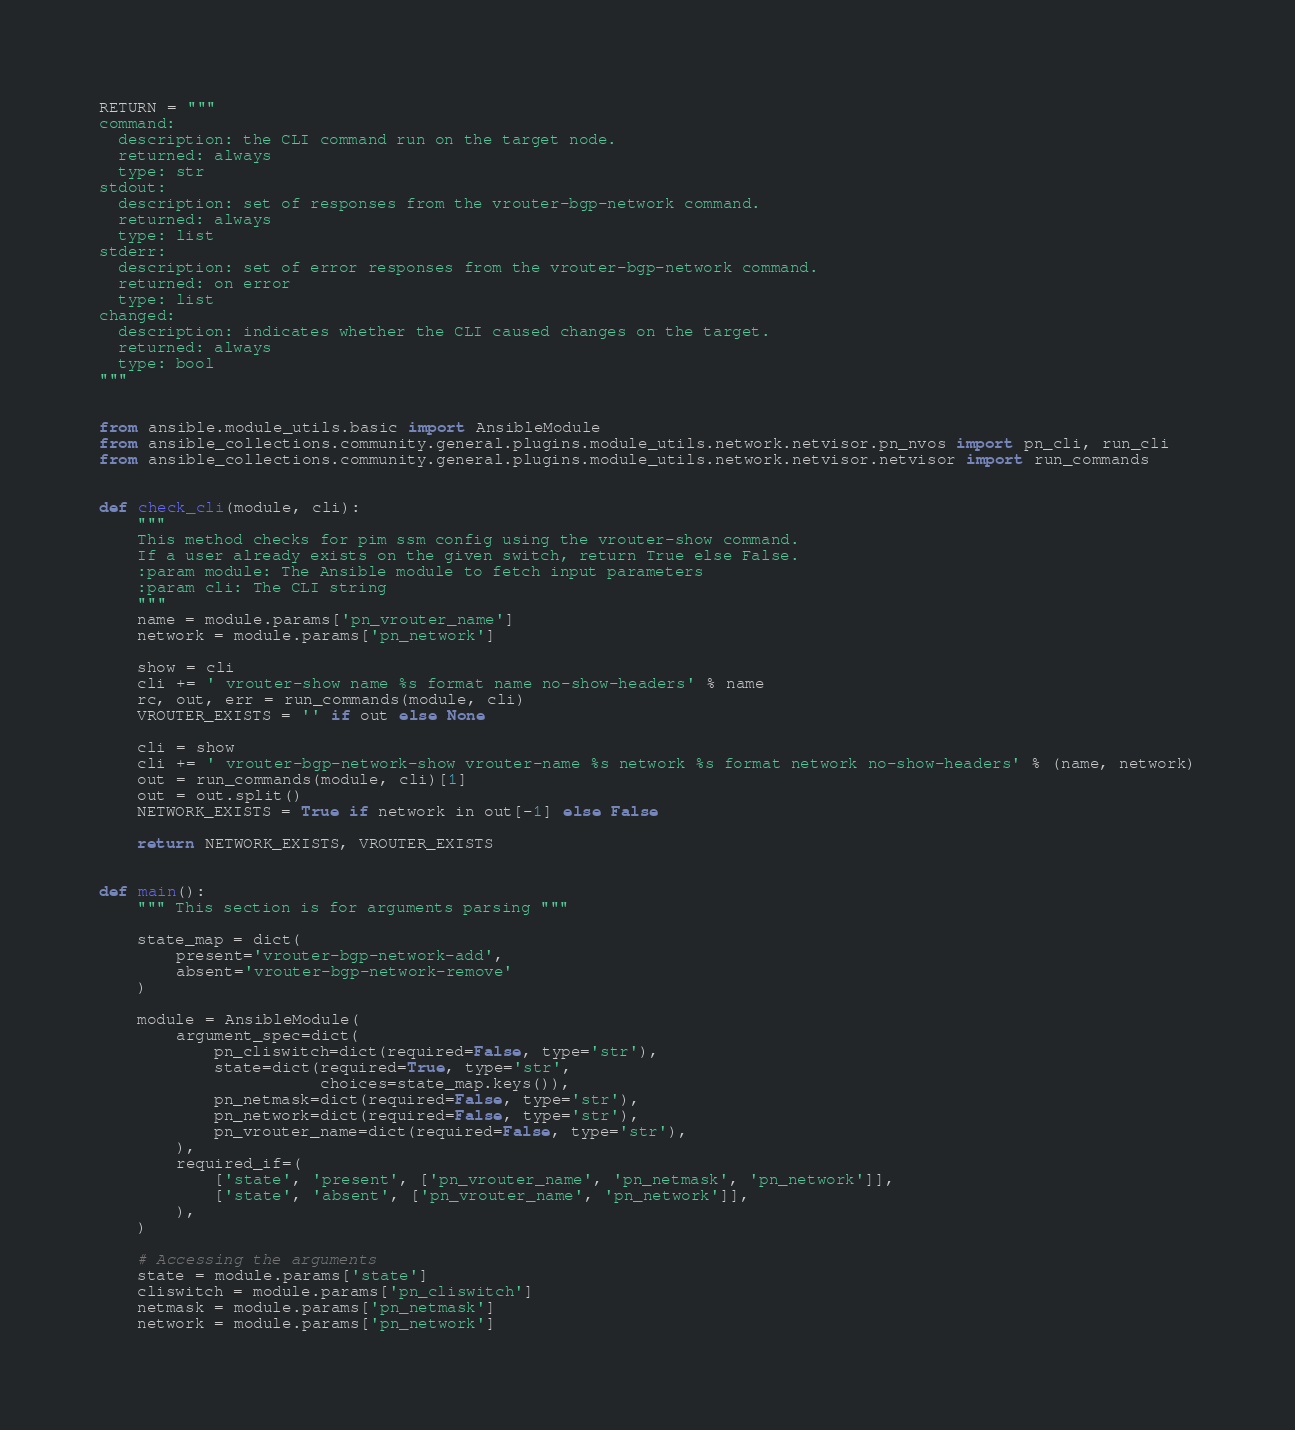<code> <loc_0><loc_0><loc_500><loc_500><_Python_>
RETURN = """
command:
  description: the CLI command run on the target node.
  returned: always
  type: str
stdout:
  description: set of responses from the vrouter-bgp-network command.
  returned: always
  type: list
stderr:
  description: set of error responses from the vrouter-bgp-network command.
  returned: on error
  type: list
changed:
  description: indicates whether the CLI caused changes on the target.
  returned: always
  type: bool
"""


from ansible.module_utils.basic import AnsibleModule
from ansible_collections.community.general.plugins.module_utils.network.netvisor.pn_nvos import pn_cli, run_cli
from ansible_collections.community.general.plugins.module_utils.network.netvisor.netvisor import run_commands


def check_cli(module, cli):
    """
    This method checks for pim ssm config using the vrouter-show command.
    If a user already exists on the given switch, return True else False.
    :param module: The Ansible module to fetch input parameters
    :param cli: The CLI string
    """
    name = module.params['pn_vrouter_name']
    network = module.params['pn_network']

    show = cli
    cli += ' vrouter-show name %s format name no-show-headers' % name
    rc, out, err = run_commands(module, cli)
    VROUTER_EXISTS = '' if out else None

    cli = show
    cli += ' vrouter-bgp-network-show vrouter-name %s network %s format network no-show-headers' % (name, network)
    out = run_commands(module, cli)[1]
    out = out.split()
    NETWORK_EXISTS = True if network in out[-1] else False

    return NETWORK_EXISTS, VROUTER_EXISTS


def main():
    """ This section is for arguments parsing """

    state_map = dict(
        present='vrouter-bgp-network-add',
        absent='vrouter-bgp-network-remove'
    )

    module = AnsibleModule(
        argument_spec=dict(
            pn_cliswitch=dict(required=False, type='str'),
            state=dict(required=True, type='str',
                       choices=state_map.keys()),
            pn_netmask=dict(required=False, type='str'),
            pn_network=dict(required=False, type='str'),
            pn_vrouter_name=dict(required=False, type='str'),
        ),
        required_if=(
            ['state', 'present', ['pn_vrouter_name', 'pn_netmask', 'pn_network']],
            ['state', 'absent', ['pn_vrouter_name', 'pn_network']],
        ),
    )

    # Accessing the arguments
    state = module.params['state']
    cliswitch = module.params['pn_cliswitch']
    netmask = module.params['pn_netmask']
    network = module.params['pn_network']</code> 